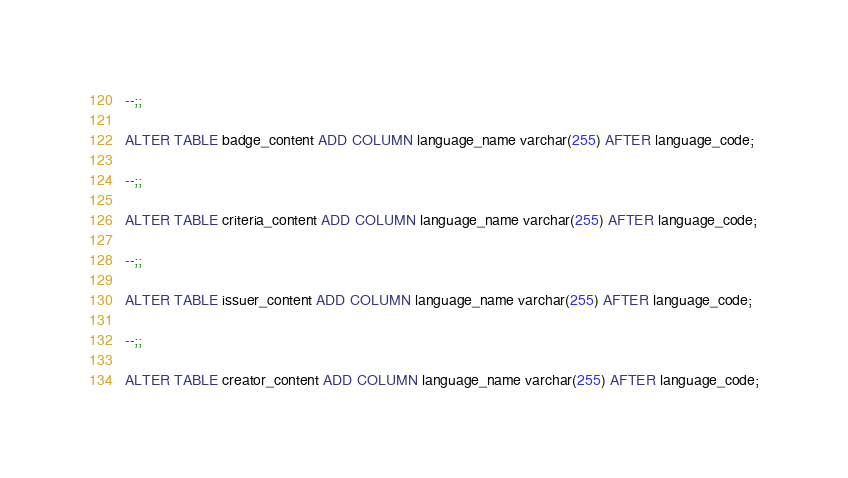<code> <loc_0><loc_0><loc_500><loc_500><_SQL_>
--;;

ALTER TABLE badge_content ADD COLUMN language_name varchar(255) AFTER language_code;

--;;

ALTER TABLE criteria_content ADD COLUMN language_name varchar(255) AFTER language_code;

--;;

ALTER TABLE issuer_content ADD COLUMN language_name varchar(255) AFTER language_code;

--;;

ALTER TABLE creator_content ADD COLUMN language_name varchar(255) AFTER language_code;
</code> 